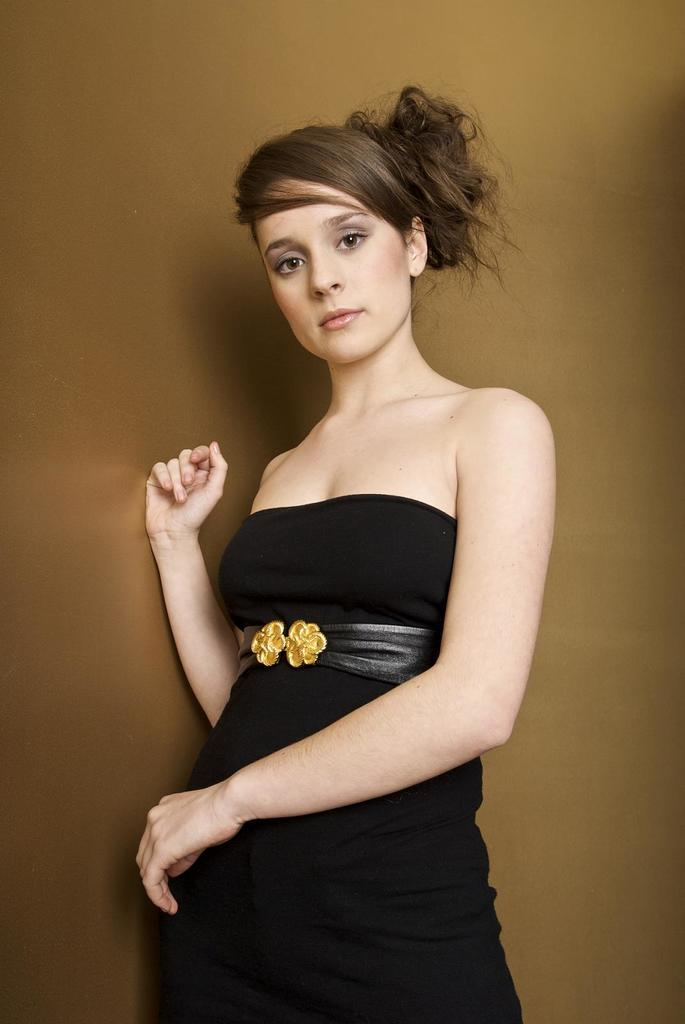What is the main subject in the image? There is a woman standing in the image. What can be observed about the background of the image? The background of the image is light brown in color. What type of stick can be seen in the woman's hand in the image? There is no stick present in the woman's hand or in the image. What kind of fruit is the woman holding in the image? There is no fruit present in the image. 